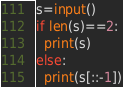<code> <loc_0><loc_0><loc_500><loc_500><_Python_>s=input()
if len(s)==2:
  print(s)
else:
  print(s[::-1])</code> 